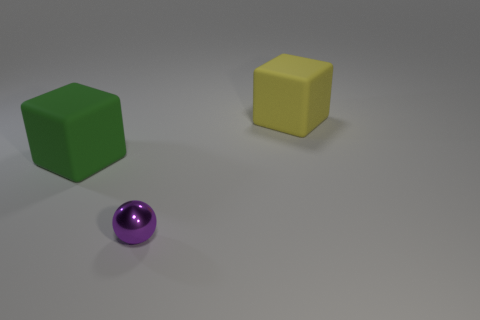Is there anything else that is made of the same material as the small sphere?
Your response must be concise. No. There is a large object behind the big green matte cube; does it have the same shape as the purple metal thing?
Offer a very short reply. No. What number of things are either tiny purple things or rubber things?
Your response must be concise. 3. Are the large thing left of the yellow object and the yellow block made of the same material?
Ensure brevity in your answer.  Yes. The purple shiny sphere is what size?
Make the answer very short. Small. How many cylinders are big green rubber things or tiny red metallic objects?
Make the answer very short. 0. Is the number of rubber things in front of the big green rubber object the same as the number of green rubber things that are in front of the yellow rubber thing?
Your answer should be compact. No. What size is the other matte object that is the same shape as the yellow rubber object?
Your answer should be compact. Large. There is a object that is both in front of the yellow block and on the right side of the large green thing; how big is it?
Offer a terse response. Small. There is a tiny thing; are there any rubber cubes left of it?
Keep it short and to the point. Yes. 